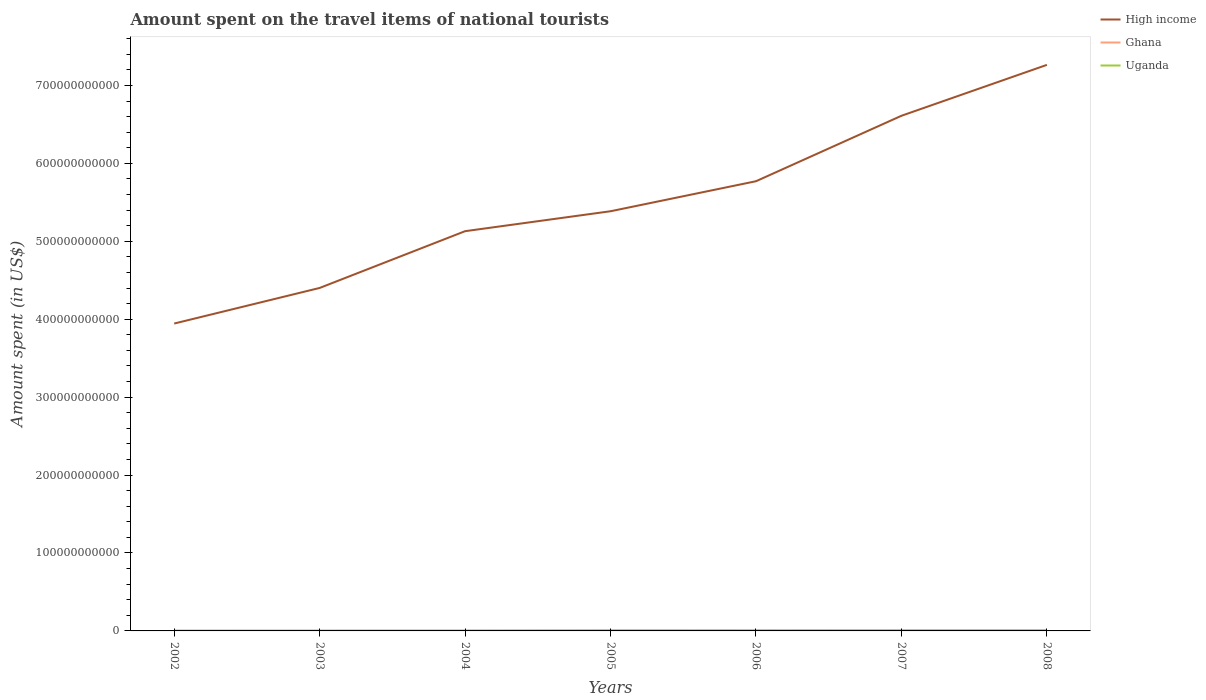How many different coloured lines are there?
Ensure brevity in your answer.  3. Does the line corresponding to Uganda intersect with the line corresponding to High income?
Your answer should be very brief. No. Is the number of lines equal to the number of legend labels?
Offer a very short reply. Yes. Across all years, what is the maximum amount spent on the travel items of national tourists in Ghana?
Your answer should be compact. 3.58e+08. What is the total amount spent on the travel items of national tourists in Uganda in the graph?
Your answer should be compact. -2.31e+08. What is the difference between the highest and the second highest amount spent on the travel items of national tourists in Ghana?
Your response must be concise. 5.61e+08. What is the difference between the highest and the lowest amount spent on the travel items of national tourists in High income?
Your response must be concise. 3. How many lines are there?
Give a very brief answer. 3. How many years are there in the graph?
Provide a short and direct response. 7. What is the difference between two consecutive major ticks on the Y-axis?
Keep it short and to the point. 1.00e+11. Does the graph contain grids?
Provide a succinct answer. No. Where does the legend appear in the graph?
Offer a very short reply. Top right. How many legend labels are there?
Your response must be concise. 3. How are the legend labels stacked?
Offer a very short reply. Vertical. What is the title of the graph?
Make the answer very short. Amount spent on the travel items of national tourists. Does "Macao" appear as one of the legend labels in the graph?
Offer a very short reply. No. What is the label or title of the X-axis?
Your response must be concise. Years. What is the label or title of the Y-axis?
Offer a very short reply. Amount spent (in US$). What is the Amount spent (in US$) in High income in 2002?
Your answer should be compact. 3.94e+11. What is the Amount spent (in US$) in Ghana in 2002?
Make the answer very short. 3.58e+08. What is the Amount spent (in US$) in Uganda in 2002?
Offer a terse response. 1.71e+08. What is the Amount spent (in US$) of High income in 2003?
Give a very brief answer. 4.40e+11. What is the Amount spent (in US$) in Ghana in 2003?
Offer a very short reply. 4.14e+08. What is the Amount spent (in US$) in Uganda in 2003?
Keep it short and to the point. 1.84e+08. What is the Amount spent (in US$) of High income in 2004?
Your answer should be very brief. 5.13e+11. What is the Amount spent (in US$) of Ghana in 2004?
Offer a terse response. 4.66e+08. What is the Amount spent (in US$) in Uganda in 2004?
Offer a terse response. 2.67e+08. What is the Amount spent (in US$) of High income in 2005?
Keep it short and to the point. 5.39e+11. What is the Amount spent (in US$) in Ghana in 2005?
Keep it short and to the point. 8.36e+08. What is the Amount spent (in US$) of Uganda in 2005?
Your response must be concise. 3.80e+08. What is the Amount spent (in US$) in High income in 2006?
Offer a terse response. 5.77e+11. What is the Amount spent (in US$) of Ghana in 2006?
Provide a short and direct response. 8.61e+08. What is the Amount spent (in US$) in Uganda in 2006?
Provide a succinct answer. 3.46e+08. What is the Amount spent (in US$) in High income in 2007?
Offer a terse response. 6.61e+11. What is the Amount spent (in US$) of Ghana in 2007?
Offer a terse response. 9.08e+08. What is the Amount spent (in US$) in Uganda in 2007?
Give a very brief answer. 3.98e+08. What is the Amount spent (in US$) in High income in 2008?
Offer a terse response. 7.26e+11. What is the Amount spent (in US$) of Ghana in 2008?
Your response must be concise. 9.19e+08. What is the Amount spent (in US$) of Uganda in 2008?
Your response must be concise. 4.98e+08. Across all years, what is the maximum Amount spent (in US$) in High income?
Give a very brief answer. 7.26e+11. Across all years, what is the maximum Amount spent (in US$) of Ghana?
Your answer should be very brief. 9.19e+08. Across all years, what is the maximum Amount spent (in US$) in Uganda?
Your answer should be very brief. 4.98e+08. Across all years, what is the minimum Amount spent (in US$) in High income?
Ensure brevity in your answer.  3.94e+11. Across all years, what is the minimum Amount spent (in US$) of Ghana?
Your answer should be compact. 3.58e+08. Across all years, what is the minimum Amount spent (in US$) of Uganda?
Ensure brevity in your answer.  1.71e+08. What is the total Amount spent (in US$) in High income in the graph?
Your answer should be very brief. 3.85e+12. What is the total Amount spent (in US$) of Ghana in the graph?
Your response must be concise. 4.76e+09. What is the total Amount spent (in US$) in Uganda in the graph?
Make the answer very short. 2.24e+09. What is the difference between the Amount spent (in US$) in High income in 2002 and that in 2003?
Your answer should be very brief. -4.57e+1. What is the difference between the Amount spent (in US$) of Ghana in 2002 and that in 2003?
Ensure brevity in your answer.  -5.60e+07. What is the difference between the Amount spent (in US$) of Uganda in 2002 and that in 2003?
Your answer should be very brief. -1.30e+07. What is the difference between the Amount spent (in US$) of High income in 2002 and that in 2004?
Offer a very short reply. -1.19e+11. What is the difference between the Amount spent (in US$) of Ghana in 2002 and that in 2004?
Offer a terse response. -1.08e+08. What is the difference between the Amount spent (in US$) of Uganda in 2002 and that in 2004?
Provide a succinct answer. -9.60e+07. What is the difference between the Amount spent (in US$) of High income in 2002 and that in 2005?
Your answer should be very brief. -1.44e+11. What is the difference between the Amount spent (in US$) of Ghana in 2002 and that in 2005?
Make the answer very short. -4.78e+08. What is the difference between the Amount spent (in US$) in Uganda in 2002 and that in 2005?
Your answer should be very brief. -2.09e+08. What is the difference between the Amount spent (in US$) of High income in 2002 and that in 2006?
Ensure brevity in your answer.  -1.83e+11. What is the difference between the Amount spent (in US$) of Ghana in 2002 and that in 2006?
Provide a succinct answer. -5.03e+08. What is the difference between the Amount spent (in US$) of Uganda in 2002 and that in 2006?
Make the answer very short. -1.75e+08. What is the difference between the Amount spent (in US$) of High income in 2002 and that in 2007?
Offer a very short reply. -2.67e+11. What is the difference between the Amount spent (in US$) of Ghana in 2002 and that in 2007?
Provide a succinct answer. -5.50e+08. What is the difference between the Amount spent (in US$) of Uganda in 2002 and that in 2007?
Keep it short and to the point. -2.27e+08. What is the difference between the Amount spent (in US$) in High income in 2002 and that in 2008?
Keep it short and to the point. -3.32e+11. What is the difference between the Amount spent (in US$) of Ghana in 2002 and that in 2008?
Your response must be concise. -5.61e+08. What is the difference between the Amount spent (in US$) of Uganda in 2002 and that in 2008?
Offer a terse response. -3.27e+08. What is the difference between the Amount spent (in US$) in High income in 2003 and that in 2004?
Provide a short and direct response. -7.29e+1. What is the difference between the Amount spent (in US$) of Ghana in 2003 and that in 2004?
Ensure brevity in your answer.  -5.20e+07. What is the difference between the Amount spent (in US$) in Uganda in 2003 and that in 2004?
Provide a succinct answer. -8.30e+07. What is the difference between the Amount spent (in US$) in High income in 2003 and that in 2005?
Your answer should be very brief. -9.84e+1. What is the difference between the Amount spent (in US$) in Ghana in 2003 and that in 2005?
Provide a short and direct response. -4.22e+08. What is the difference between the Amount spent (in US$) of Uganda in 2003 and that in 2005?
Give a very brief answer. -1.96e+08. What is the difference between the Amount spent (in US$) of High income in 2003 and that in 2006?
Your answer should be compact. -1.37e+11. What is the difference between the Amount spent (in US$) of Ghana in 2003 and that in 2006?
Ensure brevity in your answer.  -4.47e+08. What is the difference between the Amount spent (in US$) in Uganda in 2003 and that in 2006?
Your answer should be very brief. -1.62e+08. What is the difference between the Amount spent (in US$) in High income in 2003 and that in 2007?
Ensure brevity in your answer.  -2.21e+11. What is the difference between the Amount spent (in US$) in Ghana in 2003 and that in 2007?
Your answer should be compact. -4.94e+08. What is the difference between the Amount spent (in US$) in Uganda in 2003 and that in 2007?
Keep it short and to the point. -2.14e+08. What is the difference between the Amount spent (in US$) of High income in 2003 and that in 2008?
Offer a terse response. -2.86e+11. What is the difference between the Amount spent (in US$) in Ghana in 2003 and that in 2008?
Provide a short and direct response. -5.05e+08. What is the difference between the Amount spent (in US$) in Uganda in 2003 and that in 2008?
Give a very brief answer. -3.14e+08. What is the difference between the Amount spent (in US$) in High income in 2004 and that in 2005?
Ensure brevity in your answer.  -2.56e+1. What is the difference between the Amount spent (in US$) of Ghana in 2004 and that in 2005?
Keep it short and to the point. -3.70e+08. What is the difference between the Amount spent (in US$) of Uganda in 2004 and that in 2005?
Keep it short and to the point. -1.13e+08. What is the difference between the Amount spent (in US$) in High income in 2004 and that in 2006?
Ensure brevity in your answer.  -6.41e+1. What is the difference between the Amount spent (in US$) of Ghana in 2004 and that in 2006?
Your answer should be compact. -3.95e+08. What is the difference between the Amount spent (in US$) in Uganda in 2004 and that in 2006?
Ensure brevity in your answer.  -7.90e+07. What is the difference between the Amount spent (in US$) in High income in 2004 and that in 2007?
Offer a very short reply. -1.48e+11. What is the difference between the Amount spent (in US$) in Ghana in 2004 and that in 2007?
Ensure brevity in your answer.  -4.42e+08. What is the difference between the Amount spent (in US$) in Uganda in 2004 and that in 2007?
Your answer should be very brief. -1.31e+08. What is the difference between the Amount spent (in US$) in High income in 2004 and that in 2008?
Make the answer very short. -2.13e+11. What is the difference between the Amount spent (in US$) in Ghana in 2004 and that in 2008?
Ensure brevity in your answer.  -4.53e+08. What is the difference between the Amount spent (in US$) of Uganda in 2004 and that in 2008?
Keep it short and to the point. -2.31e+08. What is the difference between the Amount spent (in US$) in High income in 2005 and that in 2006?
Provide a short and direct response. -3.85e+1. What is the difference between the Amount spent (in US$) in Ghana in 2005 and that in 2006?
Keep it short and to the point. -2.50e+07. What is the difference between the Amount spent (in US$) in Uganda in 2005 and that in 2006?
Your answer should be very brief. 3.40e+07. What is the difference between the Amount spent (in US$) in High income in 2005 and that in 2007?
Your answer should be very brief. -1.23e+11. What is the difference between the Amount spent (in US$) in Ghana in 2005 and that in 2007?
Provide a succinct answer. -7.20e+07. What is the difference between the Amount spent (in US$) of Uganda in 2005 and that in 2007?
Provide a short and direct response. -1.80e+07. What is the difference between the Amount spent (in US$) in High income in 2005 and that in 2008?
Your answer should be very brief. -1.88e+11. What is the difference between the Amount spent (in US$) in Ghana in 2005 and that in 2008?
Provide a succinct answer. -8.30e+07. What is the difference between the Amount spent (in US$) in Uganda in 2005 and that in 2008?
Make the answer very short. -1.18e+08. What is the difference between the Amount spent (in US$) in High income in 2006 and that in 2007?
Offer a terse response. -8.40e+1. What is the difference between the Amount spent (in US$) in Ghana in 2006 and that in 2007?
Your response must be concise. -4.70e+07. What is the difference between the Amount spent (in US$) in Uganda in 2006 and that in 2007?
Provide a short and direct response. -5.20e+07. What is the difference between the Amount spent (in US$) in High income in 2006 and that in 2008?
Provide a succinct answer. -1.49e+11. What is the difference between the Amount spent (in US$) of Ghana in 2006 and that in 2008?
Your answer should be very brief. -5.80e+07. What is the difference between the Amount spent (in US$) in Uganda in 2006 and that in 2008?
Your answer should be compact. -1.52e+08. What is the difference between the Amount spent (in US$) of High income in 2007 and that in 2008?
Your response must be concise. -6.53e+1. What is the difference between the Amount spent (in US$) in Ghana in 2007 and that in 2008?
Your answer should be compact. -1.10e+07. What is the difference between the Amount spent (in US$) in Uganda in 2007 and that in 2008?
Make the answer very short. -1.00e+08. What is the difference between the Amount spent (in US$) in High income in 2002 and the Amount spent (in US$) in Ghana in 2003?
Keep it short and to the point. 3.94e+11. What is the difference between the Amount spent (in US$) in High income in 2002 and the Amount spent (in US$) in Uganda in 2003?
Offer a very short reply. 3.94e+11. What is the difference between the Amount spent (in US$) in Ghana in 2002 and the Amount spent (in US$) in Uganda in 2003?
Your answer should be very brief. 1.74e+08. What is the difference between the Amount spent (in US$) in High income in 2002 and the Amount spent (in US$) in Ghana in 2004?
Make the answer very short. 3.94e+11. What is the difference between the Amount spent (in US$) in High income in 2002 and the Amount spent (in US$) in Uganda in 2004?
Provide a succinct answer. 3.94e+11. What is the difference between the Amount spent (in US$) in Ghana in 2002 and the Amount spent (in US$) in Uganda in 2004?
Offer a very short reply. 9.10e+07. What is the difference between the Amount spent (in US$) of High income in 2002 and the Amount spent (in US$) of Ghana in 2005?
Your answer should be very brief. 3.94e+11. What is the difference between the Amount spent (in US$) of High income in 2002 and the Amount spent (in US$) of Uganda in 2005?
Give a very brief answer. 3.94e+11. What is the difference between the Amount spent (in US$) of Ghana in 2002 and the Amount spent (in US$) of Uganda in 2005?
Keep it short and to the point. -2.20e+07. What is the difference between the Amount spent (in US$) in High income in 2002 and the Amount spent (in US$) in Ghana in 2006?
Your answer should be compact. 3.94e+11. What is the difference between the Amount spent (in US$) in High income in 2002 and the Amount spent (in US$) in Uganda in 2006?
Offer a very short reply. 3.94e+11. What is the difference between the Amount spent (in US$) of Ghana in 2002 and the Amount spent (in US$) of Uganda in 2006?
Your answer should be very brief. 1.20e+07. What is the difference between the Amount spent (in US$) in High income in 2002 and the Amount spent (in US$) in Ghana in 2007?
Ensure brevity in your answer.  3.94e+11. What is the difference between the Amount spent (in US$) in High income in 2002 and the Amount spent (in US$) in Uganda in 2007?
Keep it short and to the point. 3.94e+11. What is the difference between the Amount spent (in US$) in Ghana in 2002 and the Amount spent (in US$) in Uganda in 2007?
Give a very brief answer. -4.00e+07. What is the difference between the Amount spent (in US$) in High income in 2002 and the Amount spent (in US$) in Ghana in 2008?
Your response must be concise. 3.94e+11. What is the difference between the Amount spent (in US$) in High income in 2002 and the Amount spent (in US$) in Uganda in 2008?
Offer a terse response. 3.94e+11. What is the difference between the Amount spent (in US$) in Ghana in 2002 and the Amount spent (in US$) in Uganda in 2008?
Provide a short and direct response. -1.40e+08. What is the difference between the Amount spent (in US$) in High income in 2003 and the Amount spent (in US$) in Ghana in 2004?
Your answer should be very brief. 4.40e+11. What is the difference between the Amount spent (in US$) in High income in 2003 and the Amount spent (in US$) in Uganda in 2004?
Your response must be concise. 4.40e+11. What is the difference between the Amount spent (in US$) in Ghana in 2003 and the Amount spent (in US$) in Uganda in 2004?
Your answer should be compact. 1.47e+08. What is the difference between the Amount spent (in US$) of High income in 2003 and the Amount spent (in US$) of Ghana in 2005?
Your answer should be compact. 4.39e+11. What is the difference between the Amount spent (in US$) of High income in 2003 and the Amount spent (in US$) of Uganda in 2005?
Offer a very short reply. 4.40e+11. What is the difference between the Amount spent (in US$) of Ghana in 2003 and the Amount spent (in US$) of Uganda in 2005?
Provide a short and direct response. 3.40e+07. What is the difference between the Amount spent (in US$) of High income in 2003 and the Amount spent (in US$) of Ghana in 2006?
Provide a succinct answer. 4.39e+11. What is the difference between the Amount spent (in US$) of High income in 2003 and the Amount spent (in US$) of Uganda in 2006?
Offer a terse response. 4.40e+11. What is the difference between the Amount spent (in US$) of Ghana in 2003 and the Amount spent (in US$) of Uganda in 2006?
Provide a short and direct response. 6.80e+07. What is the difference between the Amount spent (in US$) in High income in 2003 and the Amount spent (in US$) in Ghana in 2007?
Offer a terse response. 4.39e+11. What is the difference between the Amount spent (in US$) in High income in 2003 and the Amount spent (in US$) in Uganda in 2007?
Offer a terse response. 4.40e+11. What is the difference between the Amount spent (in US$) in Ghana in 2003 and the Amount spent (in US$) in Uganda in 2007?
Offer a very short reply. 1.60e+07. What is the difference between the Amount spent (in US$) in High income in 2003 and the Amount spent (in US$) in Ghana in 2008?
Your answer should be very brief. 4.39e+11. What is the difference between the Amount spent (in US$) of High income in 2003 and the Amount spent (in US$) of Uganda in 2008?
Ensure brevity in your answer.  4.40e+11. What is the difference between the Amount spent (in US$) of Ghana in 2003 and the Amount spent (in US$) of Uganda in 2008?
Ensure brevity in your answer.  -8.40e+07. What is the difference between the Amount spent (in US$) of High income in 2004 and the Amount spent (in US$) of Ghana in 2005?
Offer a terse response. 5.12e+11. What is the difference between the Amount spent (in US$) in High income in 2004 and the Amount spent (in US$) in Uganda in 2005?
Provide a succinct answer. 5.13e+11. What is the difference between the Amount spent (in US$) of Ghana in 2004 and the Amount spent (in US$) of Uganda in 2005?
Your answer should be very brief. 8.60e+07. What is the difference between the Amount spent (in US$) of High income in 2004 and the Amount spent (in US$) of Ghana in 2006?
Ensure brevity in your answer.  5.12e+11. What is the difference between the Amount spent (in US$) of High income in 2004 and the Amount spent (in US$) of Uganda in 2006?
Give a very brief answer. 5.13e+11. What is the difference between the Amount spent (in US$) in Ghana in 2004 and the Amount spent (in US$) in Uganda in 2006?
Your answer should be very brief. 1.20e+08. What is the difference between the Amount spent (in US$) of High income in 2004 and the Amount spent (in US$) of Ghana in 2007?
Make the answer very short. 5.12e+11. What is the difference between the Amount spent (in US$) in High income in 2004 and the Amount spent (in US$) in Uganda in 2007?
Your answer should be compact. 5.13e+11. What is the difference between the Amount spent (in US$) of Ghana in 2004 and the Amount spent (in US$) of Uganda in 2007?
Provide a succinct answer. 6.80e+07. What is the difference between the Amount spent (in US$) in High income in 2004 and the Amount spent (in US$) in Ghana in 2008?
Your response must be concise. 5.12e+11. What is the difference between the Amount spent (in US$) in High income in 2004 and the Amount spent (in US$) in Uganda in 2008?
Ensure brevity in your answer.  5.12e+11. What is the difference between the Amount spent (in US$) of Ghana in 2004 and the Amount spent (in US$) of Uganda in 2008?
Provide a short and direct response. -3.20e+07. What is the difference between the Amount spent (in US$) in High income in 2005 and the Amount spent (in US$) in Ghana in 2006?
Ensure brevity in your answer.  5.38e+11. What is the difference between the Amount spent (in US$) in High income in 2005 and the Amount spent (in US$) in Uganda in 2006?
Ensure brevity in your answer.  5.38e+11. What is the difference between the Amount spent (in US$) in Ghana in 2005 and the Amount spent (in US$) in Uganda in 2006?
Make the answer very short. 4.90e+08. What is the difference between the Amount spent (in US$) of High income in 2005 and the Amount spent (in US$) of Ghana in 2007?
Keep it short and to the point. 5.38e+11. What is the difference between the Amount spent (in US$) in High income in 2005 and the Amount spent (in US$) in Uganda in 2007?
Offer a terse response. 5.38e+11. What is the difference between the Amount spent (in US$) of Ghana in 2005 and the Amount spent (in US$) of Uganda in 2007?
Your response must be concise. 4.38e+08. What is the difference between the Amount spent (in US$) of High income in 2005 and the Amount spent (in US$) of Ghana in 2008?
Keep it short and to the point. 5.38e+11. What is the difference between the Amount spent (in US$) in High income in 2005 and the Amount spent (in US$) in Uganda in 2008?
Your response must be concise. 5.38e+11. What is the difference between the Amount spent (in US$) of Ghana in 2005 and the Amount spent (in US$) of Uganda in 2008?
Your answer should be very brief. 3.38e+08. What is the difference between the Amount spent (in US$) of High income in 2006 and the Amount spent (in US$) of Ghana in 2007?
Keep it short and to the point. 5.76e+11. What is the difference between the Amount spent (in US$) in High income in 2006 and the Amount spent (in US$) in Uganda in 2007?
Your answer should be compact. 5.77e+11. What is the difference between the Amount spent (in US$) of Ghana in 2006 and the Amount spent (in US$) of Uganda in 2007?
Provide a short and direct response. 4.63e+08. What is the difference between the Amount spent (in US$) of High income in 2006 and the Amount spent (in US$) of Ghana in 2008?
Offer a very short reply. 5.76e+11. What is the difference between the Amount spent (in US$) of High income in 2006 and the Amount spent (in US$) of Uganda in 2008?
Give a very brief answer. 5.77e+11. What is the difference between the Amount spent (in US$) of Ghana in 2006 and the Amount spent (in US$) of Uganda in 2008?
Your answer should be compact. 3.63e+08. What is the difference between the Amount spent (in US$) in High income in 2007 and the Amount spent (in US$) in Ghana in 2008?
Provide a succinct answer. 6.60e+11. What is the difference between the Amount spent (in US$) of High income in 2007 and the Amount spent (in US$) of Uganda in 2008?
Your answer should be very brief. 6.61e+11. What is the difference between the Amount spent (in US$) in Ghana in 2007 and the Amount spent (in US$) in Uganda in 2008?
Offer a terse response. 4.10e+08. What is the average Amount spent (in US$) in High income per year?
Make the answer very short. 5.50e+11. What is the average Amount spent (in US$) of Ghana per year?
Your answer should be compact. 6.80e+08. What is the average Amount spent (in US$) of Uganda per year?
Your answer should be compact. 3.21e+08. In the year 2002, what is the difference between the Amount spent (in US$) of High income and Amount spent (in US$) of Ghana?
Keep it short and to the point. 3.94e+11. In the year 2002, what is the difference between the Amount spent (in US$) of High income and Amount spent (in US$) of Uganda?
Your answer should be very brief. 3.94e+11. In the year 2002, what is the difference between the Amount spent (in US$) in Ghana and Amount spent (in US$) in Uganda?
Provide a short and direct response. 1.87e+08. In the year 2003, what is the difference between the Amount spent (in US$) in High income and Amount spent (in US$) in Ghana?
Give a very brief answer. 4.40e+11. In the year 2003, what is the difference between the Amount spent (in US$) in High income and Amount spent (in US$) in Uganda?
Offer a terse response. 4.40e+11. In the year 2003, what is the difference between the Amount spent (in US$) of Ghana and Amount spent (in US$) of Uganda?
Provide a short and direct response. 2.30e+08. In the year 2004, what is the difference between the Amount spent (in US$) of High income and Amount spent (in US$) of Ghana?
Offer a terse response. 5.13e+11. In the year 2004, what is the difference between the Amount spent (in US$) in High income and Amount spent (in US$) in Uganda?
Provide a succinct answer. 5.13e+11. In the year 2004, what is the difference between the Amount spent (in US$) in Ghana and Amount spent (in US$) in Uganda?
Provide a short and direct response. 1.99e+08. In the year 2005, what is the difference between the Amount spent (in US$) of High income and Amount spent (in US$) of Ghana?
Your answer should be compact. 5.38e+11. In the year 2005, what is the difference between the Amount spent (in US$) of High income and Amount spent (in US$) of Uganda?
Your answer should be compact. 5.38e+11. In the year 2005, what is the difference between the Amount spent (in US$) of Ghana and Amount spent (in US$) of Uganda?
Make the answer very short. 4.56e+08. In the year 2006, what is the difference between the Amount spent (in US$) in High income and Amount spent (in US$) in Ghana?
Your answer should be very brief. 5.76e+11. In the year 2006, what is the difference between the Amount spent (in US$) in High income and Amount spent (in US$) in Uganda?
Your answer should be compact. 5.77e+11. In the year 2006, what is the difference between the Amount spent (in US$) in Ghana and Amount spent (in US$) in Uganda?
Provide a succinct answer. 5.15e+08. In the year 2007, what is the difference between the Amount spent (in US$) in High income and Amount spent (in US$) in Ghana?
Ensure brevity in your answer.  6.60e+11. In the year 2007, what is the difference between the Amount spent (in US$) of High income and Amount spent (in US$) of Uganda?
Make the answer very short. 6.61e+11. In the year 2007, what is the difference between the Amount spent (in US$) of Ghana and Amount spent (in US$) of Uganda?
Provide a short and direct response. 5.10e+08. In the year 2008, what is the difference between the Amount spent (in US$) in High income and Amount spent (in US$) in Ghana?
Offer a very short reply. 7.25e+11. In the year 2008, what is the difference between the Amount spent (in US$) of High income and Amount spent (in US$) of Uganda?
Offer a very short reply. 7.26e+11. In the year 2008, what is the difference between the Amount spent (in US$) in Ghana and Amount spent (in US$) in Uganda?
Offer a very short reply. 4.21e+08. What is the ratio of the Amount spent (in US$) of High income in 2002 to that in 2003?
Offer a terse response. 0.9. What is the ratio of the Amount spent (in US$) of Ghana in 2002 to that in 2003?
Provide a succinct answer. 0.86. What is the ratio of the Amount spent (in US$) of Uganda in 2002 to that in 2003?
Your answer should be compact. 0.93. What is the ratio of the Amount spent (in US$) of High income in 2002 to that in 2004?
Offer a very short reply. 0.77. What is the ratio of the Amount spent (in US$) of Ghana in 2002 to that in 2004?
Keep it short and to the point. 0.77. What is the ratio of the Amount spent (in US$) of Uganda in 2002 to that in 2004?
Offer a terse response. 0.64. What is the ratio of the Amount spent (in US$) of High income in 2002 to that in 2005?
Your answer should be compact. 0.73. What is the ratio of the Amount spent (in US$) in Ghana in 2002 to that in 2005?
Keep it short and to the point. 0.43. What is the ratio of the Amount spent (in US$) of Uganda in 2002 to that in 2005?
Offer a terse response. 0.45. What is the ratio of the Amount spent (in US$) of High income in 2002 to that in 2006?
Offer a terse response. 0.68. What is the ratio of the Amount spent (in US$) of Ghana in 2002 to that in 2006?
Give a very brief answer. 0.42. What is the ratio of the Amount spent (in US$) of Uganda in 2002 to that in 2006?
Provide a short and direct response. 0.49. What is the ratio of the Amount spent (in US$) of High income in 2002 to that in 2007?
Offer a terse response. 0.6. What is the ratio of the Amount spent (in US$) in Ghana in 2002 to that in 2007?
Provide a short and direct response. 0.39. What is the ratio of the Amount spent (in US$) in Uganda in 2002 to that in 2007?
Make the answer very short. 0.43. What is the ratio of the Amount spent (in US$) in High income in 2002 to that in 2008?
Your response must be concise. 0.54. What is the ratio of the Amount spent (in US$) in Ghana in 2002 to that in 2008?
Keep it short and to the point. 0.39. What is the ratio of the Amount spent (in US$) of Uganda in 2002 to that in 2008?
Your response must be concise. 0.34. What is the ratio of the Amount spent (in US$) of High income in 2003 to that in 2004?
Offer a terse response. 0.86. What is the ratio of the Amount spent (in US$) in Ghana in 2003 to that in 2004?
Your answer should be compact. 0.89. What is the ratio of the Amount spent (in US$) in Uganda in 2003 to that in 2004?
Offer a very short reply. 0.69. What is the ratio of the Amount spent (in US$) of High income in 2003 to that in 2005?
Provide a succinct answer. 0.82. What is the ratio of the Amount spent (in US$) of Ghana in 2003 to that in 2005?
Offer a very short reply. 0.5. What is the ratio of the Amount spent (in US$) of Uganda in 2003 to that in 2005?
Your answer should be compact. 0.48. What is the ratio of the Amount spent (in US$) in High income in 2003 to that in 2006?
Your answer should be compact. 0.76. What is the ratio of the Amount spent (in US$) in Ghana in 2003 to that in 2006?
Ensure brevity in your answer.  0.48. What is the ratio of the Amount spent (in US$) of Uganda in 2003 to that in 2006?
Provide a short and direct response. 0.53. What is the ratio of the Amount spent (in US$) in High income in 2003 to that in 2007?
Ensure brevity in your answer.  0.67. What is the ratio of the Amount spent (in US$) in Ghana in 2003 to that in 2007?
Ensure brevity in your answer.  0.46. What is the ratio of the Amount spent (in US$) in Uganda in 2003 to that in 2007?
Provide a short and direct response. 0.46. What is the ratio of the Amount spent (in US$) in High income in 2003 to that in 2008?
Your answer should be compact. 0.61. What is the ratio of the Amount spent (in US$) of Ghana in 2003 to that in 2008?
Your response must be concise. 0.45. What is the ratio of the Amount spent (in US$) of Uganda in 2003 to that in 2008?
Make the answer very short. 0.37. What is the ratio of the Amount spent (in US$) in High income in 2004 to that in 2005?
Your answer should be very brief. 0.95. What is the ratio of the Amount spent (in US$) of Ghana in 2004 to that in 2005?
Make the answer very short. 0.56. What is the ratio of the Amount spent (in US$) of Uganda in 2004 to that in 2005?
Your answer should be compact. 0.7. What is the ratio of the Amount spent (in US$) of Ghana in 2004 to that in 2006?
Provide a short and direct response. 0.54. What is the ratio of the Amount spent (in US$) of Uganda in 2004 to that in 2006?
Offer a very short reply. 0.77. What is the ratio of the Amount spent (in US$) of High income in 2004 to that in 2007?
Provide a short and direct response. 0.78. What is the ratio of the Amount spent (in US$) of Ghana in 2004 to that in 2007?
Offer a very short reply. 0.51. What is the ratio of the Amount spent (in US$) of Uganda in 2004 to that in 2007?
Offer a very short reply. 0.67. What is the ratio of the Amount spent (in US$) in High income in 2004 to that in 2008?
Provide a succinct answer. 0.71. What is the ratio of the Amount spent (in US$) of Ghana in 2004 to that in 2008?
Your response must be concise. 0.51. What is the ratio of the Amount spent (in US$) in Uganda in 2004 to that in 2008?
Keep it short and to the point. 0.54. What is the ratio of the Amount spent (in US$) in Uganda in 2005 to that in 2006?
Your answer should be very brief. 1.1. What is the ratio of the Amount spent (in US$) of High income in 2005 to that in 2007?
Provide a short and direct response. 0.81. What is the ratio of the Amount spent (in US$) of Ghana in 2005 to that in 2007?
Offer a terse response. 0.92. What is the ratio of the Amount spent (in US$) in Uganda in 2005 to that in 2007?
Give a very brief answer. 0.95. What is the ratio of the Amount spent (in US$) of High income in 2005 to that in 2008?
Keep it short and to the point. 0.74. What is the ratio of the Amount spent (in US$) of Ghana in 2005 to that in 2008?
Offer a terse response. 0.91. What is the ratio of the Amount spent (in US$) of Uganda in 2005 to that in 2008?
Provide a succinct answer. 0.76. What is the ratio of the Amount spent (in US$) of High income in 2006 to that in 2007?
Offer a very short reply. 0.87. What is the ratio of the Amount spent (in US$) in Ghana in 2006 to that in 2007?
Provide a short and direct response. 0.95. What is the ratio of the Amount spent (in US$) of Uganda in 2006 to that in 2007?
Offer a very short reply. 0.87. What is the ratio of the Amount spent (in US$) of High income in 2006 to that in 2008?
Give a very brief answer. 0.79. What is the ratio of the Amount spent (in US$) of Ghana in 2006 to that in 2008?
Your answer should be compact. 0.94. What is the ratio of the Amount spent (in US$) of Uganda in 2006 to that in 2008?
Offer a very short reply. 0.69. What is the ratio of the Amount spent (in US$) of High income in 2007 to that in 2008?
Keep it short and to the point. 0.91. What is the ratio of the Amount spent (in US$) in Ghana in 2007 to that in 2008?
Keep it short and to the point. 0.99. What is the ratio of the Amount spent (in US$) in Uganda in 2007 to that in 2008?
Provide a succinct answer. 0.8. What is the difference between the highest and the second highest Amount spent (in US$) of High income?
Give a very brief answer. 6.53e+1. What is the difference between the highest and the second highest Amount spent (in US$) of Ghana?
Ensure brevity in your answer.  1.10e+07. What is the difference between the highest and the second highest Amount spent (in US$) of Uganda?
Provide a succinct answer. 1.00e+08. What is the difference between the highest and the lowest Amount spent (in US$) of High income?
Ensure brevity in your answer.  3.32e+11. What is the difference between the highest and the lowest Amount spent (in US$) in Ghana?
Your answer should be very brief. 5.61e+08. What is the difference between the highest and the lowest Amount spent (in US$) in Uganda?
Provide a short and direct response. 3.27e+08. 